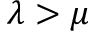<formula> <loc_0><loc_0><loc_500><loc_500>\lambda > \mu</formula> 